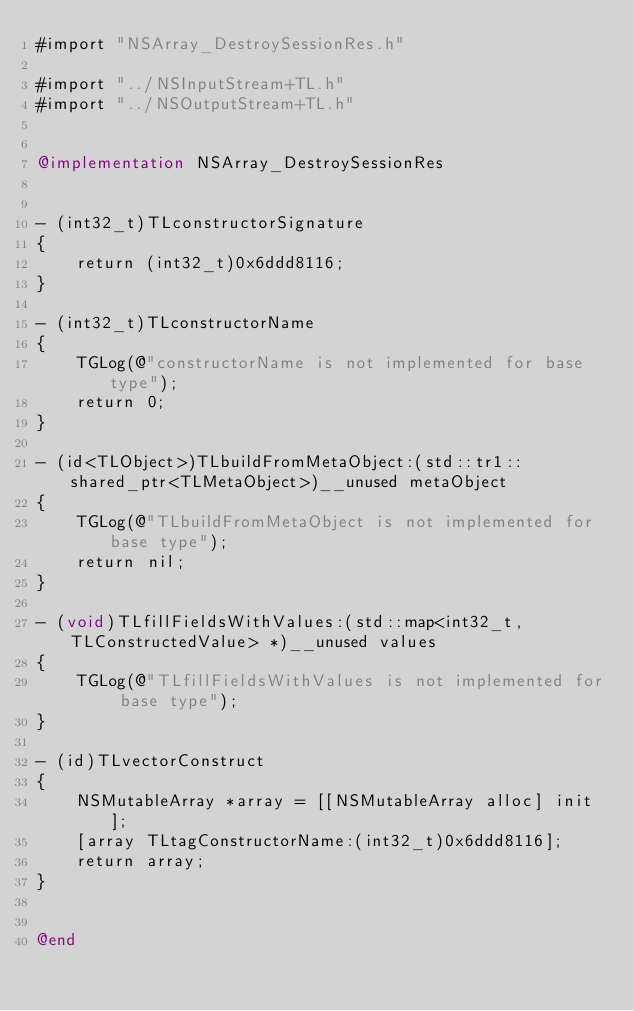Convert code to text. <code><loc_0><loc_0><loc_500><loc_500><_ObjectiveC_>#import "NSArray_DestroySessionRes.h"

#import "../NSInputStream+TL.h"
#import "../NSOutputStream+TL.h"


@implementation NSArray_DestroySessionRes


- (int32_t)TLconstructorSignature
{
    return (int32_t)0x6ddd8116;
}

- (int32_t)TLconstructorName
{
    TGLog(@"constructorName is not implemented for base type");
    return 0;
}

- (id<TLObject>)TLbuildFromMetaObject:(std::tr1::shared_ptr<TLMetaObject>)__unused metaObject
{
    TGLog(@"TLbuildFromMetaObject is not implemented for base type");
    return nil;
}

- (void)TLfillFieldsWithValues:(std::map<int32_t, TLConstructedValue> *)__unused values
{
    TGLog(@"TLfillFieldsWithValues is not implemented for base type");
}

- (id)TLvectorConstruct
{
    NSMutableArray *array = [[NSMutableArray alloc] init];
    [array TLtagConstructorName:(int32_t)0x6ddd8116];
    return array;
}


@end

</code> 